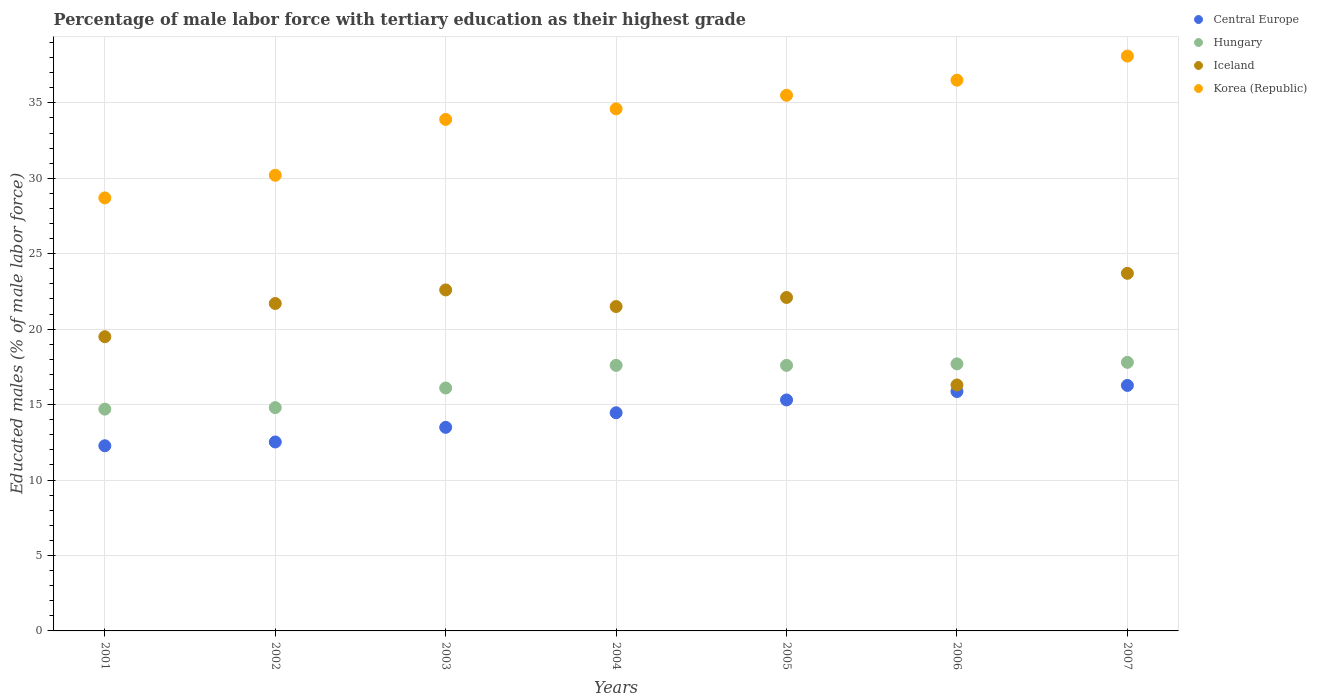How many different coloured dotlines are there?
Keep it short and to the point. 4. Is the number of dotlines equal to the number of legend labels?
Provide a succinct answer. Yes. Across all years, what is the maximum percentage of male labor force with tertiary education in Korea (Republic)?
Give a very brief answer. 38.1. Across all years, what is the minimum percentage of male labor force with tertiary education in Korea (Republic)?
Your answer should be very brief. 28.7. In which year was the percentage of male labor force with tertiary education in Hungary minimum?
Keep it short and to the point. 2001. What is the total percentage of male labor force with tertiary education in Hungary in the graph?
Keep it short and to the point. 116.3. What is the difference between the percentage of male labor force with tertiary education in Korea (Republic) in 2005 and that in 2007?
Ensure brevity in your answer.  -2.6. What is the difference between the percentage of male labor force with tertiary education in Iceland in 2004 and the percentage of male labor force with tertiary education in Hungary in 2007?
Your answer should be very brief. 3.7. What is the average percentage of male labor force with tertiary education in Korea (Republic) per year?
Your answer should be very brief. 33.93. In the year 2002, what is the difference between the percentage of male labor force with tertiary education in Korea (Republic) and percentage of male labor force with tertiary education in Central Europe?
Provide a succinct answer. 17.68. In how many years, is the percentage of male labor force with tertiary education in Korea (Republic) greater than 15 %?
Make the answer very short. 7. What is the ratio of the percentage of male labor force with tertiary education in Hungary in 2002 to that in 2005?
Offer a very short reply. 0.84. What is the difference between the highest and the second highest percentage of male labor force with tertiary education in Hungary?
Your answer should be very brief. 0.1. What is the difference between the highest and the lowest percentage of male labor force with tertiary education in Korea (Republic)?
Your answer should be very brief. 9.4. In how many years, is the percentage of male labor force with tertiary education in Korea (Republic) greater than the average percentage of male labor force with tertiary education in Korea (Republic) taken over all years?
Your answer should be very brief. 4. Does the percentage of male labor force with tertiary education in Central Europe monotonically increase over the years?
Ensure brevity in your answer.  Yes. Is the percentage of male labor force with tertiary education in Korea (Republic) strictly greater than the percentage of male labor force with tertiary education in Hungary over the years?
Provide a succinct answer. Yes. Is the percentage of male labor force with tertiary education in Iceland strictly less than the percentage of male labor force with tertiary education in Hungary over the years?
Keep it short and to the point. No. How many dotlines are there?
Keep it short and to the point. 4. Does the graph contain any zero values?
Your answer should be compact. No. Where does the legend appear in the graph?
Provide a succinct answer. Top right. How are the legend labels stacked?
Offer a terse response. Vertical. What is the title of the graph?
Make the answer very short. Percentage of male labor force with tertiary education as their highest grade. Does "Equatorial Guinea" appear as one of the legend labels in the graph?
Keep it short and to the point. No. What is the label or title of the X-axis?
Give a very brief answer. Years. What is the label or title of the Y-axis?
Make the answer very short. Educated males (% of male labor force). What is the Educated males (% of male labor force) of Central Europe in 2001?
Offer a terse response. 12.27. What is the Educated males (% of male labor force) of Hungary in 2001?
Make the answer very short. 14.7. What is the Educated males (% of male labor force) in Korea (Republic) in 2001?
Your answer should be very brief. 28.7. What is the Educated males (% of male labor force) of Central Europe in 2002?
Give a very brief answer. 12.52. What is the Educated males (% of male labor force) in Hungary in 2002?
Your response must be concise. 14.8. What is the Educated males (% of male labor force) of Iceland in 2002?
Provide a succinct answer. 21.7. What is the Educated males (% of male labor force) in Korea (Republic) in 2002?
Provide a short and direct response. 30.2. What is the Educated males (% of male labor force) of Central Europe in 2003?
Ensure brevity in your answer.  13.49. What is the Educated males (% of male labor force) in Hungary in 2003?
Your answer should be very brief. 16.1. What is the Educated males (% of male labor force) of Iceland in 2003?
Offer a terse response. 22.6. What is the Educated males (% of male labor force) of Korea (Republic) in 2003?
Provide a succinct answer. 33.9. What is the Educated males (% of male labor force) in Central Europe in 2004?
Your response must be concise. 14.46. What is the Educated males (% of male labor force) of Hungary in 2004?
Offer a very short reply. 17.6. What is the Educated males (% of male labor force) in Iceland in 2004?
Ensure brevity in your answer.  21.5. What is the Educated males (% of male labor force) in Korea (Republic) in 2004?
Give a very brief answer. 34.6. What is the Educated males (% of male labor force) of Central Europe in 2005?
Give a very brief answer. 15.31. What is the Educated males (% of male labor force) in Hungary in 2005?
Your response must be concise. 17.6. What is the Educated males (% of male labor force) in Iceland in 2005?
Offer a terse response. 22.1. What is the Educated males (% of male labor force) in Korea (Republic) in 2005?
Offer a terse response. 35.5. What is the Educated males (% of male labor force) in Central Europe in 2006?
Provide a succinct answer. 15.87. What is the Educated males (% of male labor force) of Hungary in 2006?
Your answer should be very brief. 17.7. What is the Educated males (% of male labor force) in Iceland in 2006?
Your response must be concise. 16.3. What is the Educated males (% of male labor force) of Korea (Republic) in 2006?
Your answer should be very brief. 36.5. What is the Educated males (% of male labor force) of Central Europe in 2007?
Offer a terse response. 16.27. What is the Educated males (% of male labor force) of Hungary in 2007?
Provide a short and direct response. 17.8. What is the Educated males (% of male labor force) in Iceland in 2007?
Make the answer very short. 23.7. What is the Educated males (% of male labor force) in Korea (Republic) in 2007?
Give a very brief answer. 38.1. Across all years, what is the maximum Educated males (% of male labor force) of Central Europe?
Keep it short and to the point. 16.27. Across all years, what is the maximum Educated males (% of male labor force) of Hungary?
Keep it short and to the point. 17.8. Across all years, what is the maximum Educated males (% of male labor force) of Iceland?
Provide a short and direct response. 23.7. Across all years, what is the maximum Educated males (% of male labor force) in Korea (Republic)?
Provide a short and direct response. 38.1. Across all years, what is the minimum Educated males (% of male labor force) in Central Europe?
Keep it short and to the point. 12.27. Across all years, what is the minimum Educated males (% of male labor force) of Hungary?
Your answer should be very brief. 14.7. Across all years, what is the minimum Educated males (% of male labor force) of Iceland?
Your answer should be very brief. 16.3. Across all years, what is the minimum Educated males (% of male labor force) in Korea (Republic)?
Offer a terse response. 28.7. What is the total Educated males (% of male labor force) of Central Europe in the graph?
Offer a very short reply. 100.19. What is the total Educated males (% of male labor force) in Hungary in the graph?
Provide a succinct answer. 116.3. What is the total Educated males (% of male labor force) of Iceland in the graph?
Provide a short and direct response. 147.4. What is the total Educated males (% of male labor force) of Korea (Republic) in the graph?
Give a very brief answer. 237.5. What is the difference between the Educated males (% of male labor force) of Central Europe in 2001 and that in 2002?
Keep it short and to the point. -0.25. What is the difference between the Educated males (% of male labor force) of Hungary in 2001 and that in 2002?
Provide a short and direct response. -0.1. What is the difference between the Educated males (% of male labor force) in Central Europe in 2001 and that in 2003?
Your answer should be very brief. -1.22. What is the difference between the Educated males (% of male labor force) of Hungary in 2001 and that in 2003?
Make the answer very short. -1.4. What is the difference between the Educated males (% of male labor force) in Korea (Republic) in 2001 and that in 2003?
Give a very brief answer. -5.2. What is the difference between the Educated males (% of male labor force) of Central Europe in 2001 and that in 2004?
Give a very brief answer. -2.19. What is the difference between the Educated males (% of male labor force) in Hungary in 2001 and that in 2004?
Ensure brevity in your answer.  -2.9. What is the difference between the Educated males (% of male labor force) in Korea (Republic) in 2001 and that in 2004?
Provide a succinct answer. -5.9. What is the difference between the Educated males (% of male labor force) of Central Europe in 2001 and that in 2005?
Provide a short and direct response. -3.04. What is the difference between the Educated males (% of male labor force) of Hungary in 2001 and that in 2005?
Your answer should be very brief. -2.9. What is the difference between the Educated males (% of male labor force) of Korea (Republic) in 2001 and that in 2005?
Make the answer very short. -6.8. What is the difference between the Educated males (% of male labor force) of Central Europe in 2001 and that in 2006?
Offer a terse response. -3.6. What is the difference between the Educated males (% of male labor force) in Central Europe in 2001 and that in 2007?
Offer a very short reply. -4. What is the difference between the Educated males (% of male labor force) of Korea (Republic) in 2001 and that in 2007?
Ensure brevity in your answer.  -9.4. What is the difference between the Educated males (% of male labor force) of Central Europe in 2002 and that in 2003?
Give a very brief answer. -0.97. What is the difference between the Educated males (% of male labor force) of Hungary in 2002 and that in 2003?
Your answer should be very brief. -1.3. What is the difference between the Educated males (% of male labor force) in Central Europe in 2002 and that in 2004?
Provide a succinct answer. -1.94. What is the difference between the Educated males (% of male labor force) in Hungary in 2002 and that in 2004?
Offer a terse response. -2.8. What is the difference between the Educated males (% of male labor force) of Iceland in 2002 and that in 2004?
Your answer should be compact. 0.2. What is the difference between the Educated males (% of male labor force) of Korea (Republic) in 2002 and that in 2004?
Offer a terse response. -4.4. What is the difference between the Educated males (% of male labor force) of Central Europe in 2002 and that in 2005?
Ensure brevity in your answer.  -2.79. What is the difference between the Educated males (% of male labor force) of Hungary in 2002 and that in 2005?
Offer a terse response. -2.8. What is the difference between the Educated males (% of male labor force) in Iceland in 2002 and that in 2005?
Offer a very short reply. -0.4. What is the difference between the Educated males (% of male labor force) in Korea (Republic) in 2002 and that in 2005?
Provide a succinct answer. -5.3. What is the difference between the Educated males (% of male labor force) in Central Europe in 2002 and that in 2006?
Offer a terse response. -3.35. What is the difference between the Educated males (% of male labor force) in Korea (Republic) in 2002 and that in 2006?
Provide a short and direct response. -6.3. What is the difference between the Educated males (% of male labor force) of Central Europe in 2002 and that in 2007?
Your response must be concise. -3.75. What is the difference between the Educated males (% of male labor force) in Korea (Republic) in 2002 and that in 2007?
Your response must be concise. -7.9. What is the difference between the Educated males (% of male labor force) of Central Europe in 2003 and that in 2004?
Your answer should be very brief. -0.97. What is the difference between the Educated males (% of male labor force) in Hungary in 2003 and that in 2004?
Make the answer very short. -1.5. What is the difference between the Educated males (% of male labor force) of Iceland in 2003 and that in 2004?
Keep it short and to the point. 1.1. What is the difference between the Educated males (% of male labor force) in Central Europe in 2003 and that in 2005?
Your answer should be compact. -1.82. What is the difference between the Educated males (% of male labor force) of Korea (Republic) in 2003 and that in 2005?
Provide a short and direct response. -1.6. What is the difference between the Educated males (% of male labor force) of Central Europe in 2003 and that in 2006?
Ensure brevity in your answer.  -2.37. What is the difference between the Educated males (% of male labor force) of Hungary in 2003 and that in 2006?
Your response must be concise. -1.6. What is the difference between the Educated males (% of male labor force) of Korea (Republic) in 2003 and that in 2006?
Provide a succinct answer. -2.6. What is the difference between the Educated males (% of male labor force) in Central Europe in 2003 and that in 2007?
Provide a short and direct response. -2.78. What is the difference between the Educated males (% of male labor force) of Iceland in 2003 and that in 2007?
Your response must be concise. -1.1. What is the difference between the Educated males (% of male labor force) in Central Europe in 2004 and that in 2005?
Give a very brief answer. -0.85. What is the difference between the Educated males (% of male labor force) in Korea (Republic) in 2004 and that in 2005?
Your answer should be very brief. -0.9. What is the difference between the Educated males (% of male labor force) in Central Europe in 2004 and that in 2006?
Give a very brief answer. -1.41. What is the difference between the Educated males (% of male labor force) of Iceland in 2004 and that in 2006?
Provide a succinct answer. 5.2. What is the difference between the Educated males (% of male labor force) of Korea (Republic) in 2004 and that in 2006?
Provide a short and direct response. -1.9. What is the difference between the Educated males (% of male labor force) of Central Europe in 2004 and that in 2007?
Make the answer very short. -1.81. What is the difference between the Educated males (% of male labor force) of Hungary in 2004 and that in 2007?
Provide a short and direct response. -0.2. What is the difference between the Educated males (% of male labor force) of Iceland in 2004 and that in 2007?
Make the answer very short. -2.2. What is the difference between the Educated males (% of male labor force) of Korea (Republic) in 2004 and that in 2007?
Provide a short and direct response. -3.5. What is the difference between the Educated males (% of male labor force) of Central Europe in 2005 and that in 2006?
Keep it short and to the point. -0.56. What is the difference between the Educated males (% of male labor force) in Iceland in 2005 and that in 2006?
Your answer should be compact. 5.8. What is the difference between the Educated males (% of male labor force) of Korea (Republic) in 2005 and that in 2006?
Make the answer very short. -1. What is the difference between the Educated males (% of male labor force) in Central Europe in 2005 and that in 2007?
Your answer should be compact. -0.96. What is the difference between the Educated males (% of male labor force) in Hungary in 2005 and that in 2007?
Offer a very short reply. -0.2. What is the difference between the Educated males (% of male labor force) of Korea (Republic) in 2005 and that in 2007?
Your response must be concise. -2.6. What is the difference between the Educated males (% of male labor force) in Central Europe in 2006 and that in 2007?
Your answer should be compact. -0.4. What is the difference between the Educated males (% of male labor force) of Iceland in 2006 and that in 2007?
Your answer should be compact. -7.4. What is the difference between the Educated males (% of male labor force) of Central Europe in 2001 and the Educated males (% of male labor force) of Hungary in 2002?
Make the answer very short. -2.53. What is the difference between the Educated males (% of male labor force) in Central Europe in 2001 and the Educated males (% of male labor force) in Iceland in 2002?
Make the answer very short. -9.43. What is the difference between the Educated males (% of male labor force) in Central Europe in 2001 and the Educated males (% of male labor force) in Korea (Republic) in 2002?
Offer a very short reply. -17.93. What is the difference between the Educated males (% of male labor force) in Hungary in 2001 and the Educated males (% of male labor force) in Iceland in 2002?
Ensure brevity in your answer.  -7. What is the difference between the Educated males (% of male labor force) in Hungary in 2001 and the Educated males (% of male labor force) in Korea (Republic) in 2002?
Keep it short and to the point. -15.5. What is the difference between the Educated males (% of male labor force) in Iceland in 2001 and the Educated males (% of male labor force) in Korea (Republic) in 2002?
Ensure brevity in your answer.  -10.7. What is the difference between the Educated males (% of male labor force) of Central Europe in 2001 and the Educated males (% of male labor force) of Hungary in 2003?
Offer a very short reply. -3.83. What is the difference between the Educated males (% of male labor force) of Central Europe in 2001 and the Educated males (% of male labor force) of Iceland in 2003?
Offer a very short reply. -10.33. What is the difference between the Educated males (% of male labor force) in Central Europe in 2001 and the Educated males (% of male labor force) in Korea (Republic) in 2003?
Offer a terse response. -21.63. What is the difference between the Educated males (% of male labor force) in Hungary in 2001 and the Educated males (% of male labor force) in Iceland in 2003?
Offer a very short reply. -7.9. What is the difference between the Educated males (% of male labor force) of Hungary in 2001 and the Educated males (% of male labor force) of Korea (Republic) in 2003?
Your answer should be compact. -19.2. What is the difference between the Educated males (% of male labor force) in Iceland in 2001 and the Educated males (% of male labor force) in Korea (Republic) in 2003?
Provide a short and direct response. -14.4. What is the difference between the Educated males (% of male labor force) of Central Europe in 2001 and the Educated males (% of male labor force) of Hungary in 2004?
Provide a short and direct response. -5.33. What is the difference between the Educated males (% of male labor force) in Central Europe in 2001 and the Educated males (% of male labor force) in Iceland in 2004?
Offer a terse response. -9.23. What is the difference between the Educated males (% of male labor force) of Central Europe in 2001 and the Educated males (% of male labor force) of Korea (Republic) in 2004?
Your answer should be very brief. -22.33. What is the difference between the Educated males (% of male labor force) in Hungary in 2001 and the Educated males (% of male labor force) in Korea (Republic) in 2004?
Your answer should be compact. -19.9. What is the difference between the Educated males (% of male labor force) in Iceland in 2001 and the Educated males (% of male labor force) in Korea (Republic) in 2004?
Offer a very short reply. -15.1. What is the difference between the Educated males (% of male labor force) in Central Europe in 2001 and the Educated males (% of male labor force) in Hungary in 2005?
Give a very brief answer. -5.33. What is the difference between the Educated males (% of male labor force) in Central Europe in 2001 and the Educated males (% of male labor force) in Iceland in 2005?
Offer a terse response. -9.83. What is the difference between the Educated males (% of male labor force) of Central Europe in 2001 and the Educated males (% of male labor force) of Korea (Republic) in 2005?
Offer a very short reply. -23.23. What is the difference between the Educated males (% of male labor force) in Hungary in 2001 and the Educated males (% of male labor force) in Korea (Republic) in 2005?
Provide a short and direct response. -20.8. What is the difference between the Educated males (% of male labor force) in Iceland in 2001 and the Educated males (% of male labor force) in Korea (Republic) in 2005?
Offer a terse response. -16. What is the difference between the Educated males (% of male labor force) of Central Europe in 2001 and the Educated males (% of male labor force) of Hungary in 2006?
Provide a short and direct response. -5.43. What is the difference between the Educated males (% of male labor force) in Central Europe in 2001 and the Educated males (% of male labor force) in Iceland in 2006?
Your answer should be compact. -4.03. What is the difference between the Educated males (% of male labor force) in Central Europe in 2001 and the Educated males (% of male labor force) in Korea (Republic) in 2006?
Offer a terse response. -24.23. What is the difference between the Educated males (% of male labor force) of Hungary in 2001 and the Educated males (% of male labor force) of Iceland in 2006?
Your answer should be compact. -1.6. What is the difference between the Educated males (% of male labor force) in Hungary in 2001 and the Educated males (% of male labor force) in Korea (Republic) in 2006?
Ensure brevity in your answer.  -21.8. What is the difference between the Educated males (% of male labor force) in Central Europe in 2001 and the Educated males (% of male labor force) in Hungary in 2007?
Ensure brevity in your answer.  -5.53. What is the difference between the Educated males (% of male labor force) of Central Europe in 2001 and the Educated males (% of male labor force) of Iceland in 2007?
Your answer should be compact. -11.43. What is the difference between the Educated males (% of male labor force) in Central Europe in 2001 and the Educated males (% of male labor force) in Korea (Republic) in 2007?
Your answer should be very brief. -25.83. What is the difference between the Educated males (% of male labor force) in Hungary in 2001 and the Educated males (% of male labor force) in Korea (Republic) in 2007?
Keep it short and to the point. -23.4. What is the difference between the Educated males (% of male labor force) in Iceland in 2001 and the Educated males (% of male labor force) in Korea (Republic) in 2007?
Offer a very short reply. -18.6. What is the difference between the Educated males (% of male labor force) in Central Europe in 2002 and the Educated males (% of male labor force) in Hungary in 2003?
Offer a very short reply. -3.58. What is the difference between the Educated males (% of male labor force) of Central Europe in 2002 and the Educated males (% of male labor force) of Iceland in 2003?
Give a very brief answer. -10.08. What is the difference between the Educated males (% of male labor force) of Central Europe in 2002 and the Educated males (% of male labor force) of Korea (Republic) in 2003?
Keep it short and to the point. -21.38. What is the difference between the Educated males (% of male labor force) of Hungary in 2002 and the Educated males (% of male labor force) of Korea (Republic) in 2003?
Your answer should be very brief. -19.1. What is the difference between the Educated males (% of male labor force) in Central Europe in 2002 and the Educated males (% of male labor force) in Hungary in 2004?
Your answer should be very brief. -5.08. What is the difference between the Educated males (% of male labor force) of Central Europe in 2002 and the Educated males (% of male labor force) of Iceland in 2004?
Provide a short and direct response. -8.98. What is the difference between the Educated males (% of male labor force) of Central Europe in 2002 and the Educated males (% of male labor force) of Korea (Republic) in 2004?
Your answer should be compact. -22.08. What is the difference between the Educated males (% of male labor force) of Hungary in 2002 and the Educated males (% of male labor force) of Korea (Republic) in 2004?
Your response must be concise. -19.8. What is the difference between the Educated males (% of male labor force) in Central Europe in 2002 and the Educated males (% of male labor force) in Hungary in 2005?
Your answer should be very brief. -5.08. What is the difference between the Educated males (% of male labor force) of Central Europe in 2002 and the Educated males (% of male labor force) of Iceland in 2005?
Provide a short and direct response. -9.58. What is the difference between the Educated males (% of male labor force) of Central Europe in 2002 and the Educated males (% of male labor force) of Korea (Republic) in 2005?
Make the answer very short. -22.98. What is the difference between the Educated males (% of male labor force) in Hungary in 2002 and the Educated males (% of male labor force) in Iceland in 2005?
Your answer should be compact. -7.3. What is the difference between the Educated males (% of male labor force) of Hungary in 2002 and the Educated males (% of male labor force) of Korea (Republic) in 2005?
Provide a succinct answer. -20.7. What is the difference between the Educated males (% of male labor force) in Central Europe in 2002 and the Educated males (% of male labor force) in Hungary in 2006?
Give a very brief answer. -5.18. What is the difference between the Educated males (% of male labor force) of Central Europe in 2002 and the Educated males (% of male labor force) of Iceland in 2006?
Make the answer very short. -3.78. What is the difference between the Educated males (% of male labor force) in Central Europe in 2002 and the Educated males (% of male labor force) in Korea (Republic) in 2006?
Your answer should be compact. -23.98. What is the difference between the Educated males (% of male labor force) in Hungary in 2002 and the Educated males (% of male labor force) in Iceland in 2006?
Make the answer very short. -1.5. What is the difference between the Educated males (% of male labor force) of Hungary in 2002 and the Educated males (% of male labor force) of Korea (Republic) in 2006?
Offer a very short reply. -21.7. What is the difference between the Educated males (% of male labor force) in Iceland in 2002 and the Educated males (% of male labor force) in Korea (Republic) in 2006?
Offer a very short reply. -14.8. What is the difference between the Educated males (% of male labor force) in Central Europe in 2002 and the Educated males (% of male labor force) in Hungary in 2007?
Offer a very short reply. -5.28. What is the difference between the Educated males (% of male labor force) in Central Europe in 2002 and the Educated males (% of male labor force) in Iceland in 2007?
Give a very brief answer. -11.18. What is the difference between the Educated males (% of male labor force) of Central Europe in 2002 and the Educated males (% of male labor force) of Korea (Republic) in 2007?
Give a very brief answer. -25.58. What is the difference between the Educated males (% of male labor force) of Hungary in 2002 and the Educated males (% of male labor force) of Iceland in 2007?
Offer a very short reply. -8.9. What is the difference between the Educated males (% of male labor force) in Hungary in 2002 and the Educated males (% of male labor force) in Korea (Republic) in 2007?
Keep it short and to the point. -23.3. What is the difference between the Educated males (% of male labor force) in Iceland in 2002 and the Educated males (% of male labor force) in Korea (Republic) in 2007?
Provide a succinct answer. -16.4. What is the difference between the Educated males (% of male labor force) of Central Europe in 2003 and the Educated males (% of male labor force) of Hungary in 2004?
Provide a succinct answer. -4.11. What is the difference between the Educated males (% of male labor force) in Central Europe in 2003 and the Educated males (% of male labor force) in Iceland in 2004?
Ensure brevity in your answer.  -8.01. What is the difference between the Educated males (% of male labor force) in Central Europe in 2003 and the Educated males (% of male labor force) in Korea (Republic) in 2004?
Your answer should be compact. -21.11. What is the difference between the Educated males (% of male labor force) in Hungary in 2003 and the Educated males (% of male labor force) in Korea (Republic) in 2004?
Make the answer very short. -18.5. What is the difference between the Educated males (% of male labor force) in Iceland in 2003 and the Educated males (% of male labor force) in Korea (Republic) in 2004?
Make the answer very short. -12. What is the difference between the Educated males (% of male labor force) of Central Europe in 2003 and the Educated males (% of male labor force) of Hungary in 2005?
Your answer should be compact. -4.11. What is the difference between the Educated males (% of male labor force) in Central Europe in 2003 and the Educated males (% of male labor force) in Iceland in 2005?
Ensure brevity in your answer.  -8.61. What is the difference between the Educated males (% of male labor force) in Central Europe in 2003 and the Educated males (% of male labor force) in Korea (Republic) in 2005?
Give a very brief answer. -22.01. What is the difference between the Educated males (% of male labor force) in Hungary in 2003 and the Educated males (% of male labor force) in Iceland in 2005?
Offer a terse response. -6. What is the difference between the Educated males (% of male labor force) in Hungary in 2003 and the Educated males (% of male labor force) in Korea (Republic) in 2005?
Make the answer very short. -19.4. What is the difference between the Educated males (% of male labor force) of Central Europe in 2003 and the Educated males (% of male labor force) of Hungary in 2006?
Offer a terse response. -4.21. What is the difference between the Educated males (% of male labor force) in Central Europe in 2003 and the Educated males (% of male labor force) in Iceland in 2006?
Provide a short and direct response. -2.81. What is the difference between the Educated males (% of male labor force) in Central Europe in 2003 and the Educated males (% of male labor force) in Korea (Republic) in 2006?
Your answer should be very brief. -23.01. What is the difference between the Educated males (% of male labor force) of Hungary in 2003 and the Educated males (% of male labor force) of Iceland in 2006?
Your response must be concise. -0.2. What is the difference between the Educated males (% of male labor force) in Hungary in 2003 and the Educated males (% of male labor force) in Korea (Republic) in 2006?
Keep it short and to the point. -20.4. What is the difference between the Educated males (% of male labor force) in Iceland in 2003 and the Educated males (% of male labor force) in Korea (Republic) in 2006?
Your answer should be compact. -13.9. What is the difference between the Educated males (% of male labor force) in Central Europe in 2003 and the Educated males (% of male labor force) in Hungary in 2007?
Ensure brevity in your answer.  -4.31. What is the difference between the Educated males (% of male labor force) of Central Europe in 2003 and the Educated males (% of male labor force) of Iceland in 2007?
Provide a short and direct response. -10.21. What is the difference between the Educated males (% of male labor force) of Central Europe in 2003 and the Educated males (% of male labor force) of Korea (Republic) in 2007?
Keep it short and to the point. -24.61. What is the difference between the Educated males (% of male labor force) in Hungary in 2003 and the Educated males (% of male labor force) in Iceland in 2007?
Ensure brevity in your answer.  -7.6. What is the difference between the Educated males (% of male labor force) of Iceland in 2003 and the Educated males (% of male labor force) of Korea (Republic) in 2007?
Your response must be concise. -15.5. What is the difference between the Educated males (% of male labor force) in Central Europe in 2004 and the Educated males (% of male labor force) in Hungary in 2005?
Make the answer very short. -3.14. What is the difference between the Educated males (% of male labor force) of Central Europe in 2004 and the Educated males (% of male labor force) of Iceland in 2005?
Provide a succinct answer. -7.64. What is the difference between the Educated males (% of male labor force) in Central Europe in 2004 and the Educated males (% of male labor force) in Korea (Republic) in 2005?
Give a very brief answer. -21.04. What is the difference between the Educated males (% of male labor force) of Hungary in 2004 and the Educated males (% of male labor force) of Iceland in 2005?
Your answer should be very brief. -4.5. What is the difference between the Educated males (% of male labor force) of Hungary in 2004 and the Educated males (% of male labor force) of Korea (Republic) in 2005?
Make the answer very short. -17.9. What is the difference between the Educated males (% of male labor force) in Iceland in 2004 and the Educated males (% of male labor force) in Korea (Republic) in 2005?
Provide a short and direct response. -14. What is the difference between the Educated males (% of male labor force) in Central Europe in 2004 and the Educated males (% of male labor force) in Hungary in 2006?
Keep it short and to the point. -3.24. What is the difference between the Educated males (% of male labor force) in Central Europe in 2004 and the Educated males (% of male labor force) in Iceland in 2006?
Offer a terse response. -1.84. What is the difference between the Educated males (% of male labor force) of Central Europe in 2004 and the Educated males (% of male labor force) of Korea (Republic) in 2006?
Provide a short and direct response. -22.04. What is the difference between the Educated males (% of male labor force) in Hungary in 2004 and the Educated males (% of male labor force) in Iceland in 2006?
Give a very brief answer. 1.3. What is the difference between the Educated males (% of male labor force) in Hungary in 2004 and the Educated males (% of male labor force) in Korea (Republic) in 2006?
Offer a terse response. -18.9. What is the difference between the Educated males (% of male labor force) in Iceland in 2004 and the Educated males (% of male labor force) in Korea (Republic) in 2006?
Your response must be concise. -15. What is the difference between the Educated males (% of male labor force) of Central Europe in 2004 and the Educated males (% of male labor force) of Hungary in 2007?
Your answer should be compact. -3.34. What is the difference between the Educated males (% of male labor force) in Central Europe in 2004 and the Educated males (% of male labor force) in Iceland in 2007?
Make the answer very short. -9.24. What is the difference between the Educated males (% of male labor force) of Central Europe in 2004 and the Educated males (% of male labor force) of Korea (Republic) in 2007?
Give a very brief answer. -23.64. What is the difference between the Educated males (% of male labor force) in Hungary in 2004 and the Educated males (% of male labor force) in Korea (Republic) in 2007?
Offer a very short reply. -20.5. What is the difference between the Educated males (% of male labor force) in Iceland in 2004 and the Educated males (% of male labor force) in Korea (Republic) in 2007?
Give a very brief answer. -16.6. What is the difference between the Educated males (% of male labor force) of Central Europe in 2005 and the Educated males (% of male labor force) of Hungary in 2006?
Offer a very short reply. -2.39. What is the difference between the Educated males (% of male labor force) in Central Europe in 2005 and the Educated males (% of male labor force) in Iceland in 2006?
Provide a short and direct response. -0.99. What is the difference between the Educated males (% of male labor force) of Central Europe in 2005 and the Educated males (% of male labor force) of Korea (Republic) in 2006?
Your answer should be compact. -21.19. What is the difference between the Educated males (% of male labor force) in Hungary in 2005 and the Educated males (% of male labor force) in Korea (Republic) in 2006?
Offer a terse response. -18.9. What is the difference between the Educated males (% of male labor force) in Iceland in 2005 and the Educated males (% of male labor force) in Korea (Republic) in 2006?
Make the answer very short. -14.4. What is the difference between the Educated males (% of male labor force) of Central Europe in 2005 and the Educated males (% of male labor force) of Hungary in 2007?
Your response must be concise. -2.49. What is the difference between the Educated males (% of male labor force) in Central Europe in 2005 and the Educated males (% of male labor force) in Iceland in 2007?
Keep it short and to the point. -8.39. What is the difference between the Educated males (% of male labor force) of Central Europe in 2005 and the Educated males (% of male labor force) of Korea (Republic) in 2007?
Provide a succinct answer. -22.79. What is the difference between the Educated males (% of male labor force) of Hungary in 2005 and the Educated males (% of male labor force) of Iceland in 2007?
Keep it short and to the point. -6.1. What is the difference between the Educated males (% of male labor force) of Hungary in 2005 and the Educated males (% of male labor force) of Korea (Republic) in 2007?
Give a very brief answer. -20.5. What is the difference between the Educated males (% of male labor force) in Central Europe in 2006 and the Educated males (% of male labor force) in Hungary in 2007?
Provide a succinct answer. -1.93. What is the difference between the Educated males (% of male labor force) in Central Europe in 2006 and the Educated males (% of male labor force) in Iceland in 2007?
Your answer should be very brief. -7.83. What is the difference between the Educated males (% of male labor force) of Central Europe in 2006 and the Educated males (% of male labor force) of Korea (Republic) in 2007?
Keep it short and to the point. -22.23. What is the difference between the Educated males (% of male labor force) of Hungary in 2006 and the Educated males (% of male labor force) of Korea (Republic) in 2007?
Keep it short and to the point. -20.4. What is the difference between the Educated males (% of male labor force) of Iceland in 2006 and the Educated males (% of male labor force) of Korea (Republic) in 2007?
Keep it short and to the point. -21.8. What is the average Educated males (% of male labor force) in Central Europe per year?
Offer a terse response. 14.31. What is the average Educated males (% of male labor force) of Hungary per year?
Your response must be concise. 16.61. What is the average Educated males (% of male labor force) of Iceland per year?
Your response must be concise. 21.06. What is the average Educated males (% of male labor force) of Korea (Republic) per year?
Make the answer very short. 33.93. In the year 2001, what is the difference between the Educated males (% of male labor force) in Central Europe and Educated males (% of male labor force) in Hungary?
Make the answer very short. -2.43. In the year 2001, what is the difference between the Educated males (% of male labor force) in Central Europe and Educated males (% of male labor force) in Iceland?
Offer a very short reply. -7.23. In the year 2001, what is the difference between the Educated males (% of male labor force) of Central Europe and Educated males (% of male labor force) of Korea (Republic)?
Make the answer very short. -16.43. In the year 2001, what is the difference between the Educated males (% of male labor force) in Hungary and Educated males (% of male labor force) in Korea (Republic)?
Your response must be concise. -14. In the year 2002, what is the difference between the Educated males (% of male labor force) in Central Europe and Educated males (% of male labor force) in Hungary?
Offer a terse response. -2.28. In the year 2002, what is the difference between the Educated males (% of male labor force) of Central Europe and Educated males (% of male labor force) of Iceland?
Make the answer very short. -9.18. In the year 2002, what is the difference between the Educated males (% of male labor force) in Central Europe and Educated males (% of male labor force) in Korea (Republic)?
Offer a terse response. -17.68. In the year 2002, what is the difference between the Educated males (% of male labor force) of Hungary and Educated males (% of male labor force) of Korea (Republic)?
Offer a terse response. -15.4. In the year 2003, what is the difference between the Educated males (% of male labor force) of Central Europe and Educated males (% of male labor force) of Hungary?
Ensure brevity in your answer.  -2.61. In the year 2003, what is the difference between the Educated males (% of male labor force) of Central Europe and Educated males (% of male labor force) of Iceland?
Give a very brief answer. -9.11. In the year 2003, what is the difference between the Educated males (% of male labor force) of Central Europe and Educated males (% of male labor force) of Korea (Republic)?
Your response must be concise. -20.41. In the year 2003, what is the difference between the Educated males (% of male labor force) of Hungary and Educated males (% of male labor force) of Korea (Republic)?
Provide a short and direct response. -17.8. In the year 2003, what is the difference between the Educated males (% of male labor force) of Iceland and Educated males (% of male labor force) of Korea (Republic)?
Provide a succinct answer. -11.3. In the year 2004, what is the difference between the Educated males (% of male labor force) in Central Europe and Educated males (% of male labor force) in Hungary?
Your response must be concise. -3.14. In the year 2004, what is the difference between the Educated males (% of male labor force) in Central Europe and Educated males (% of male labor force) in Iceland?
Provide a short and direct response. -7.04. In the year 2004, what is the difference between the Educated males (% of male labor force) of Central Europe and Educated males (% of male labor force) of Korea (Republic)?
Offer a very short reply. -20.14. In the year 2004, what is the difference between the Educated males (% of male labor force) of Hungary and Educated males (% of male labor force) of Iceland?
Your answer should be compact. -3.9. In the year 2005, what is the difference between the Educated males (% of male labor force) of Central Europe and Educated males (% of male labor force) of Hungary?
Your response must be concise. -2.29. In the year 2005, what is the difference between the Educated males (% of male labor force) of Central Europe and Educated males (% of male labor force) of Iceland?
Offer a terse response. -6.79. In the year 2005, what is the difference between the Educated males (% of male labor force) in Central Europe and Educated males (% of male labor force) in Korea (Republic)?
Offer a very short reply. -20.19. In the year 2005, what is the difference between the Educated males (% of male labor force) in Hungary and Educated males (% of male labor force) in Iceland?
Your answer should be very brief. -4.5. In the year 2005, what is the difference between the Educated males (% of male labor force) of Hungary and Educated males (% of male labor force) of Korea (Republic)?
Make the answer very short. -17.9. In the year 2006, what is the difference between the Educated males (% of male labor force) of Central Europe and Educated males (% of male labor force) of Hungary?
Offer a very short reply. -1.83. In the year 2006, what is the difference between the Educated males (% of male labor force) in Central Europe and Educated males (% of male labor force) in Iceland?
Offer a very short reply. -0.43. In the year 2006, what is the difference between the Educated males (% of male labor force) in Central Europe and Educated males (% of male labor force) in Korea (Republic)?
Your answer should be compact. -20.63. In the year 2006, what is the difference between the Educated males (% of male labor force) in Hungary and Educated males (% of male labor force) in Iceland?
Ensure brevity in your answer.  1.4. In the year 2006, what is the difference between the Educated males (% of male labor force) in Hungary and Educated males (% of male labor force) in Korea (Republic)?
Keep it short and to the point. -18.8. In the year 2006, what is the difference between the Educated males (% of male labor force) in Iceland and Educated males (% of male labor force) in Korea (Republic)?
Offer a very short reply. -20.2. In the year 2007, what is the difference between the Educated males (% of male labor force) of Central Europe and Educated males (% of male labor force) of Hungary?
Your answer should be compact. -1.53. In the year 2007, what is the difference between the Educated males (% of male labor force) in Central Europe and Educated males (% of male labor force) in Iceland?
Give a very brief answer. -7.43. In the year 2007, what is the difference between the Educated males (% of male labor force) in Central Europe and Educated males (% of male labor force) in Korea (Republic)?
Ensure brevity in your answer.  -21.83. In the year 2007, what is the difference between the Educated males (% of male labor force) in Hungary and Educated males (% of male labor force) in Korea (Republic)?
Give a very brief answer. -20.3. In the year 2007, what is the difference between the Educated males (% of male labor force) in Iceland and Educated males (% of male labor force) in Korea (Republic)?
Provide a succinct answer. -14.4. What is the ratio of the Educated males (% of male labor force) of Hungary in 2001 to that in 2002?
Offer a terse response. 0.99. What is the ratio of the Educated males (% of male labor force) in Iceland in 2001 to that in 2002?
Ensure brevity in your answer.  0.9. What is the ratio of the Educated males (% of male labor force) of Korea (Republic) in 2001 to that in 2002?
Provide a short and direct response. 0.95. What is the ratio of the Educated males (% of male labor force) in Central Europe in 2001 to that in 2003?
Provide a succinct answer. 0.91. What is the ratio of the Educated males (% of male labor force) in Iceland in 2001 to that in 2003?
Offer a very short reply. 0.86. What is the ratio of the Educated males (% of male labor force) in Korea (Republic) in 2001 to that in 2003?
Offer a very short reply. 0.85. What is the ratio of the Educated males (% of male labor force) in Central Europe in 2001 to that in 2004?
Provide a succinct answer. 0.85. What is the ratio of the Educated males (% of male labor force) in Hungary in 2001 to that in 2004?
Your answer should be very brief. 0.84. What is the ratio of the Educated males (% of male labor force) of Iceland in 2001 to that in 2004?
Provide a short and direct response. 0.91. What is the ratio of the Educated males (% of male labor force) of Korea (Republic) in 2001 to that in 2004?
Provide a succinct answer. 0.83. What is the ratio of the Educated males (% of male labor force) in Central Europe in 2001 to that in 2005?
Your response must be concise. 0.8. What is the ratio of the Educated males (% of male labor force) of Hungary in 2001 to that in 2005?
Ensure brevity in your answer.  0.84. What is the ratio of the Educated males (% of male labor force) of Iceland in 2001 to that in 2005?
Give a very brief answer. 0.88. What is the ratio of the Educated males (% of male labor force) in Korea (Republic) in 2001 to that in 2005?
Keep it short and to the point. 0.81. What is the ratio of the Educated males (% of male labor force) of Central Europe in 2001 to that in 2006?
Ensure brevity in your answer.  0.77. What is the ratio of the Educated males (% of male labor force) of Hungary in 2001 to that in 2006?
Your answer should be compact. 0.83. What is the ratio of the Educated males (% of male labor force) in Iceland in 2001 to that in 2006?
Make the answer very short. 1.2. What is the ratio of the Educated males (% of male labor force) in Korea (Republic) in 2001 to that in 2006?
Give a very brief answer. 0.79. What is the ratio of the Educated males (% of male labor force) in Central Europe in 2001 to that in 2007?
Your answer should be compact. 0.75. What is the ratio of the Educated males (% of male labor force) of Hungary in 2001 to that in 2007?
Provide a succinct answer. 0.83. What is the ratio of the Educated males (% of male labor force) of Iceland in 2001 to that in 2007?
Provide a succinct answer. 0.82. What is the ratio of the Educated males (% of male labor force) of Korea (Republic) in 2001 to that in 2007?
Keep it short and to the point. 0.75. What is the ratio of the Educated males (% of male labor force) of Central Europe in 2002 to that in 2003?
Make the answer very short. 0.93. What is the ratio of the Educated males (% of male labor force) in Hungary in 2002 to that in 2003?
Your response must be concise. 0.92. What is the ratio of the Educated males (% of male labor force) in Iceland in 2002 to that in 2003?
Ensure brevity in your answer.  0.96. What is the ratio of the Educated males (% of male labor force) in Korea (Republic) in 2002 to that in 2003?
Give a very brief answer. 0.89. What is the ratio of the Educated males (% of male labor force) in Central Europe in 2002 to that in 2004?
Offer a terse response. 0.87. What is the ratio of the Educated males (% of male labor force) in Hungary in 2002 to that in 2004?
Your answer should be compact. 0.84. What is the ratio of the Educated males (% of male labor force) of Iceland in 2002 to that in 2004?
Offer a very short reply. 1.01. What is the ratio of the Educated males (% of male labor force) of Korea (Republic) in 2002 to that in 2004?
Offer a terse response. 0.87. What is the ratio of the Educated males (% of male labor force) in Central Europe in 2002 to that in 2005?
Give a very brief answer. 0.82. What is the ratio of the Educated males (% of male labor force) in Hungary in 2002 to that in 2005?
Keep it short and to the point. 0.84. What is the ratio of the Educated males (% of male labor force) in Iceland in 2002 to that in 2005?
Your response must be concise. 0.98. What is the ratio of the Educated males (% of male labor force) in Korea (Republic) in 2002 to that in 2005?
Ensure brevity in your answer.  0.85. What is the ratio of the Educated males (% of male labor force) in Central Europe in 2002 to that in 2006?
Make the answer very short. 0.79. What is the ratio of the Educated males (% of male labor force) in Hungary in 2002 to that in 2006?
Provide a short and direct response. 0.84. What is the ratio of the Educated males (% of male labor force) of Iceland in 2002 to that in 2006?
Your response must be concise. 1.33. What is the ratio of the Educated males (% of male labor force) in Korea (Republic) in 2002 to that in 2006?
Give a very brief answer. 0.83. What is the ratio of the Educated males (% of male labor force) in Central Europe in 2002 to that in 2007?
Provide a short and direct response. 0.77. What is the ratio of the Educated males (% of male labor force) in Hungary in 2002 to that in 2007?
Your response must be concise. 0.83. What is the ratio of the Educated males (% of male labor force) of Iceland in 2002 to that in 2007?
Provide a succinct answer. 0.92. What is the ratio of the Educated males (% of male labor force) in Korea (Republic) in 2002 to that in 2007?
Make the answer very short. 0.79. What is the ratio of the Educated males (% of male labor force) of Central Europe in 2003 to that in 2004?
Your answer should be very brief. 0.93. What is the ratio of the Educated males (% of male labor force) of Hungary in 2003 to that in 2004?
Offer a very short reply. 0.91. What is the ratio of the Educated males (% of male labor force) of Iceland in 2003 to that in 2004?
Ensure brevity in your answer.  1.05. What is the ratio of the Educated males (% of male labor force) of Korea (Republic) in 2003 to that in 2004?
Make the answer very short. 0.98. What is the ratio of the Educated males (% of male labor force) in Central Europe in 2003 to that in 2005?
Ensure brevity in your answer.  0.88. What is the ratio of the Educated males (% of male labor force) of Hungary in 2003 to that in 2005?
Your response must be concise. 0.91. What is the ratio of the Educated males (% of male labor force) in Iceland in 2003 to that in 2005?
Ensure brevity in your answer.  1.02. What is the ratio of the Educated males (% of male labor force) in Korea (Republic) in 2003 to that in 2005?
Ensure brevity in your answer.  0.95. What is the ratio of the Educated males (% of male labor force) of Central Europe in 2003 to that in 2006?
Your answer should be very brief. 0.85. What is the ratio of the Educated males (% of male labor force) in Hungary in 2003 to that in 2006?
Make the answer very short. 0.91. What is the ratio of the Educated males (% of male labor force) in Iceland in 2003 to that in 2006?
Give a very brief answer. 1.39. What is the ratio of the Educated males (% of male labor force) of Korea (Republic) in 2003 to that in 2006?
Ensure brevity in your answer.  0.93. What is the ratio of the Educated males (% of male labor force) in Central Europe in 2003 to that in 2007?
Make the answer very short. 0.83. What is the ratio of the Educated males (% of male labor force) in Hungary in 2003 to that in 2007?
Offer a very short reply. 0.9. What is the ratio of the Educated males (% of male labor force) of Iceland in 2003 to that in 2007?
Make the answer very short. 0.95. What is the ratio of the Educated males (% of male labor force) of Korea (Republic) in 2003 to that in 2007?
Ensure brevity in your answer.  0.89. What is the ratio of the Educated males (% of male labor force) in Central Europe in 2004 to that in 2005?
Offer a very short reply. 0.94. What is the ratio of the Educated males (% of male labor force) in Iceland in 2004 to that in 2005?
Offer a terse response. 0.97. What is the ratio of the Educated males (% of male labor force) of Korea (Republic) in 2004 to that in 2005?
Ensure brevity in your answer.  0.97. What is the ratio of the Educated males (% of male labor force) of Central Europe in 2004 to that in 2006?
Provide a short and direct response. 0.91. What is the ratio of the Educated males (% of male labor force) in Hungary in 2004 to that in 2006?
Ensure brevity in your answer.  0.99. What is the ratio of the Educated males (% of male labor force) in Iceland in 2004 to that in 2006?
Offer a terse response. 1.32. What is the ratio of the Educated males (% of male labor force) in Korea (Republic) in 2004 to that in 2006?
Provide a succinct answer. 0.95. What is the ratio of the Educated males (% of male labor force) of Central Europe in 2004 to that in 2007?
Make the answer very short. 0.89. What is the ratio of the Educated males (% of male labor force) in Hungary in 2004 to that in 2007?
Provide a short and direct response. 0.99. What is the ratio of the Educated males (% of male labor force) in Iceland in 2004 to that in 2007?
Your answer should be very brief. 0.91. What is the ratio of the Educated males (% of male labor force) of Korea (Republic) in 2004 to that in 2007?
Your answer should be very brief. 0.91. What is the ratio of the Educated males (% of male labor force) in Central Europe in 2005 to that in 2006?
Offer a very short reply. 0.96. What is the ratio of the Educated males (% of male labor force) in Iceland in 2005 to that in 2006?
Offer a terse response. 1.36. What is the ratio of the Educated males (% of male labor force) in Korea (Republic) in 2005 to that in 2006?
Offer a very short reply. 0.97. What is the ratio of the Educated males (% of male labor force) in Central Europe in 2005 to that in 2007?
Ensure brevity in your answer.  0.94. What is the ratio of the Educated males (% of male labor force) of Iceland in 2005 to that in 2007?
Provide a succinct answer. 0.93. What is the ratio of the Educated males (% of male labor force) in Korea (Republic) in 2005 to that in 2007?
Your response must be concise. 0.93. What is the ratio of the Educated males (% of male labor force) in Central Europe in 2006 to that in 2007?
Your response must be concise. 0.98. What is the ratio of the Educated males (% of male labor force) in Iceland in 2006 to that in 2007?
Keep it short and to the point. 0.69. What is the ratio of the Educated males (% of male labor force) in Korea (Republic) in 2006 to that in 2007?
Make the answer very short. 0.96. What is the difference between the highest and the second highest Educated males (% of male labor force) of Central Europe?
Give a very brief answer. 0.4. What is the difference between the highest and the second highest Educated males (% of male labor force) of Hungary?
Offer a terse response. 0.1. What is the difference between the highest and the lowest Educated males (% of male labor force) in Central Europe?
Provide a short and direct response. 4. What is the difference between the highest and the lowest Educated males (% of male labor force) in Iceland?
Offer a very short reply. 7.4. 